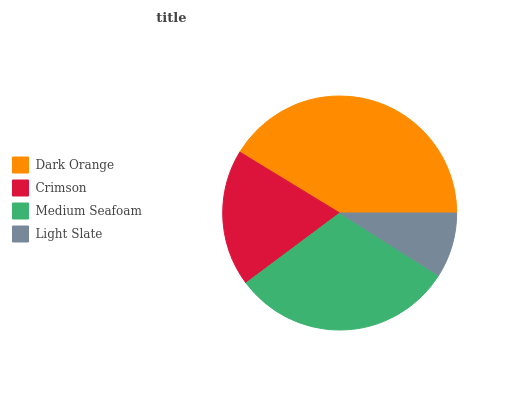Is Light Slate the minimum?
Answer yes or no. Yes. Is Dark Orange the maximum?
Answer yes or no. Yes. Is Crimson the minimum?
Answer yes or no. No. Is Crimson the maximum?
Answer yes or no. No. Is Dark Orange greater than Crimson?
Answer yes or no. Yes. Is Crimson less than Dark Orange?
Answer yes or no. Yes. Is Crimson greater than Dark Orange?
Answer yes or no. No. Is Dark Orange less than Crimson?
Answer yes or no. No. Is Medium Seafoam the high median?
Answer yes or no. Yes. Is Crimson the low median?
Answer yes or no. Yes. Is Crimson the high median?
Answer yes or no. No. Is Medium Seafoam the low median?
Answer yes or no. No. 